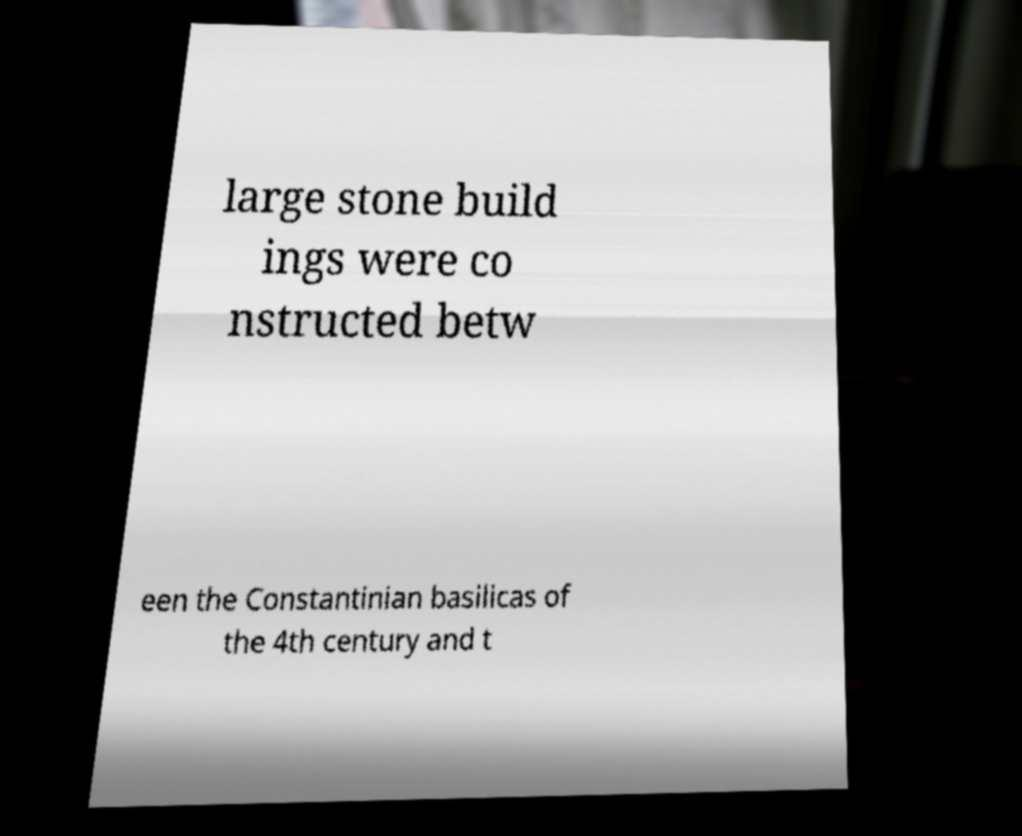What messages or text are displayed in this image? I need them in a readable, typed format. large stone build ings were co nstructed betw een the Constantinian basilicas of the 4th century and t 